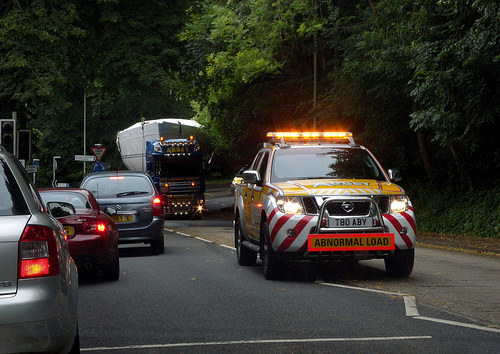<image>
Is the car on the asphalt? Yes. Looking at the image, I can see the car is positioned on top of the asphalt, with the asphalt providing support. 